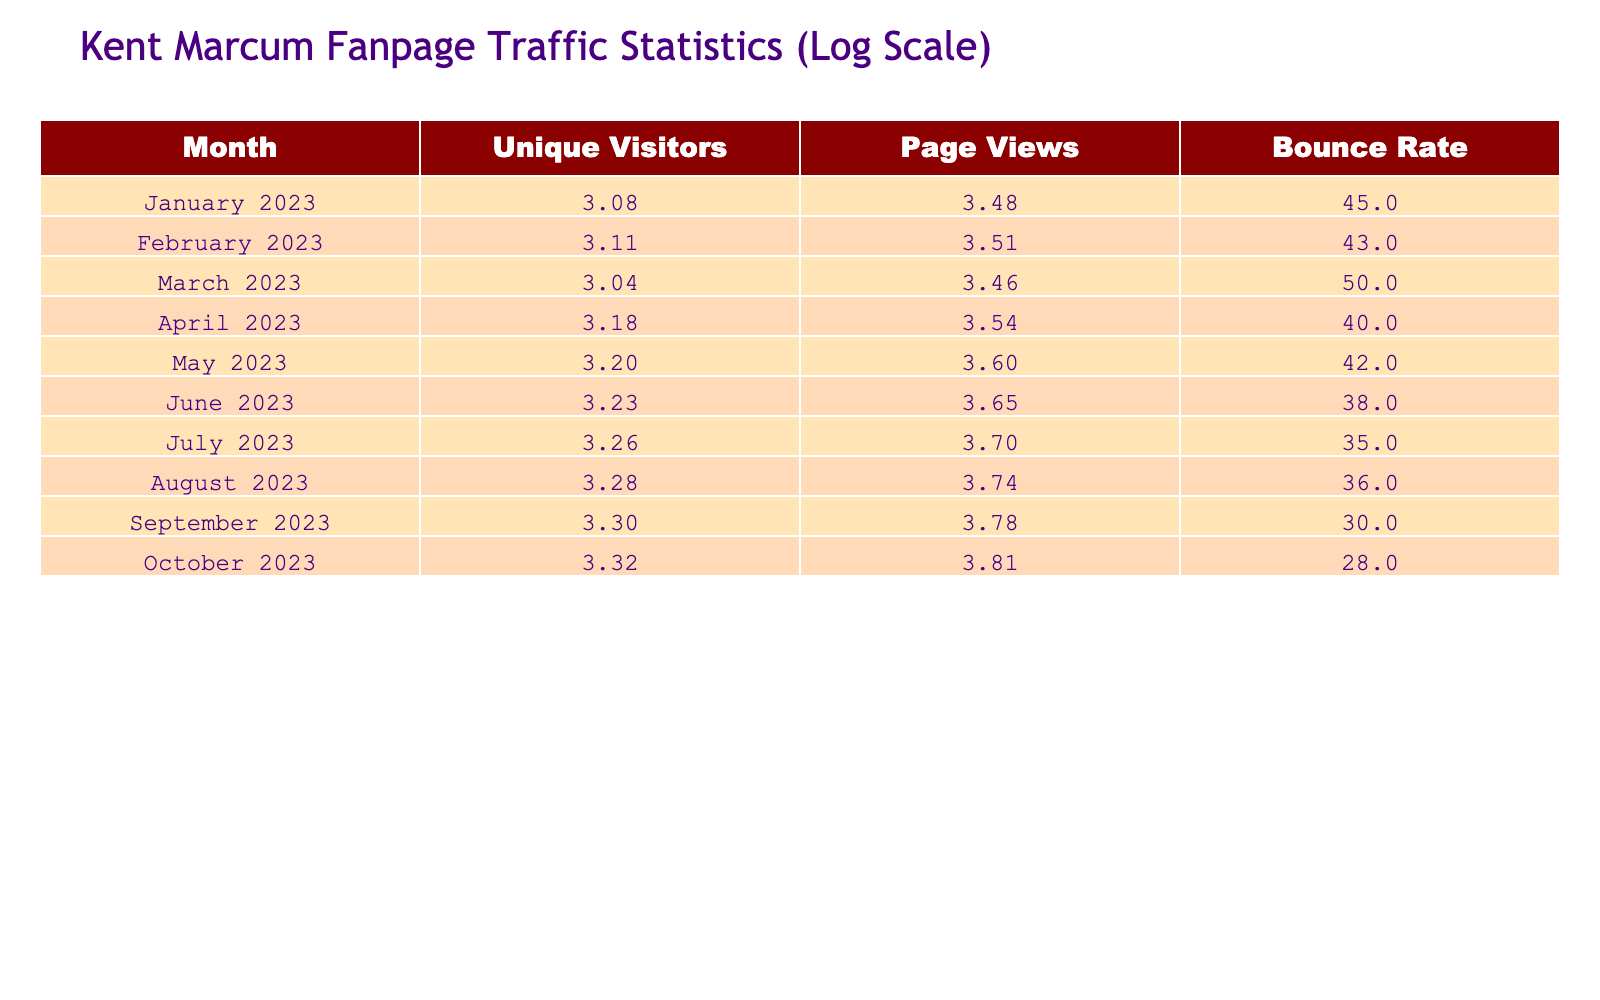What was the unique visitors count in September 2023? The table shows the data for unique visitors in the month of September 2023. By directly reading the relevant cell, I find that the unique visitors count is 2000.
Answer: 2000 What is the bounce rate for April 2023? To find the bounce rate for April 2023, I check the corresponding cell in the table. It states that the bounce rate for this month is 40.
Answer: 40 In which month did the fanpage have the highest unique visitors? I look for the highest value in the "Unique Visitors" column. August 2023 has the highest count of unique visitors at 1900.
Answer: August 2023 What is the average page views for the first half of 2023? First, I need to sum the page views from January to June (3000 + 3200 + 2900 + 3500 + 4000 + 4500 = 20900). There are 6 months in the first half of the year, so I calculate the average: 20900 / 6 = 3483.33.
Answer: 3483.33 Is the bounce rate in October lower than in January? To answer this, I compare the bounce rates for October and January. January has a bounce rate of 45, while October has a bounce rate of 28. Since 28 is less than 45, the statement is true.
Answer: Yes What month had the highest increase in unique visitors compared to the previous month? I compare the unique visitors month-over-month. The increases are: February (100), March (-200), April (400), May (100), June (100), July (100), August (100), September (100), and October (100). The biggest increase is 400 from March to April.
Answer: April 2023 How many unique visitors were there in total from January to October 2023? I total the unique visitors from each month: 1200 + 1300 + 1100 + 1500 + 1600 + 1700 + 1800 + 1900 + 2000 + 2100 = 13900.
Answer: 13900 Is it true that the page views decreased from March to April? I check the page views for March (2900) and April (3500). Since 3500 is greater than 2900, the page views actually increased. Thus, the statement is false.
Answer: No What was the percentage increase in unique visitors from June to July 2023? I compare the unique visitors: June has 1700 and July has 1800. The increase is 1800 - 1700 = 100. To find the percentage increase: (100 / 1700) * 100 = approximately 5.88%.
Answer: 5.88% 